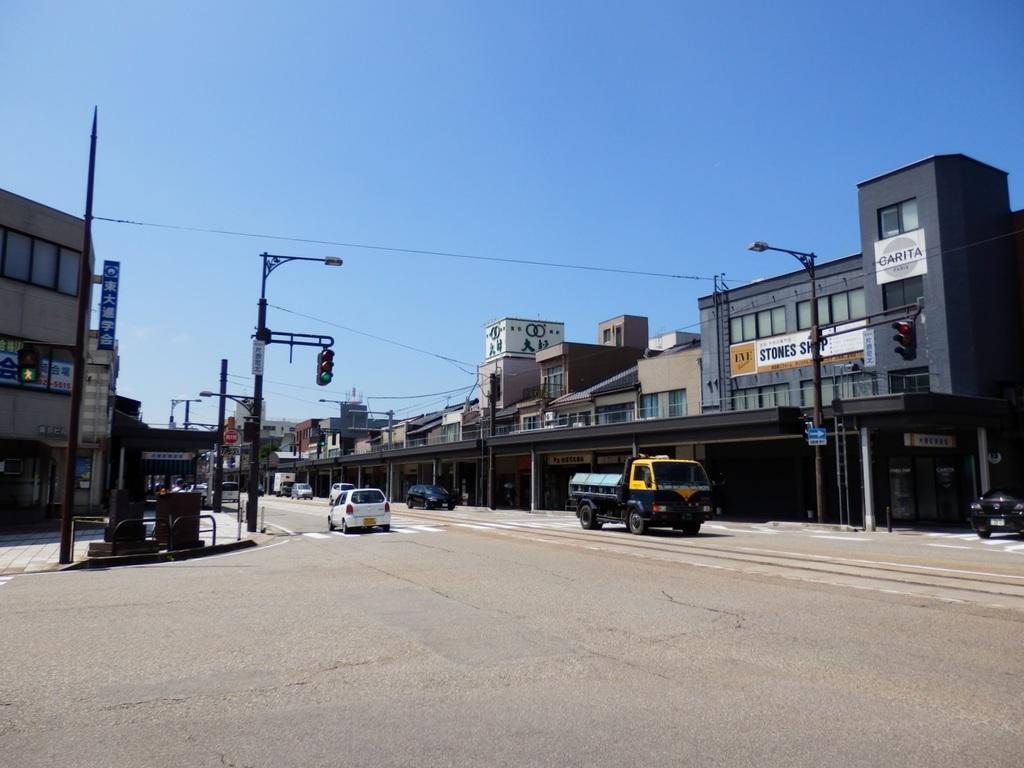Describe this image in one or two sentences. In the center of the image there are buildings and we can see poles. There is a traffic light. At the bottom there is a road and we can see vehicles on the road. In the background there is sky. 